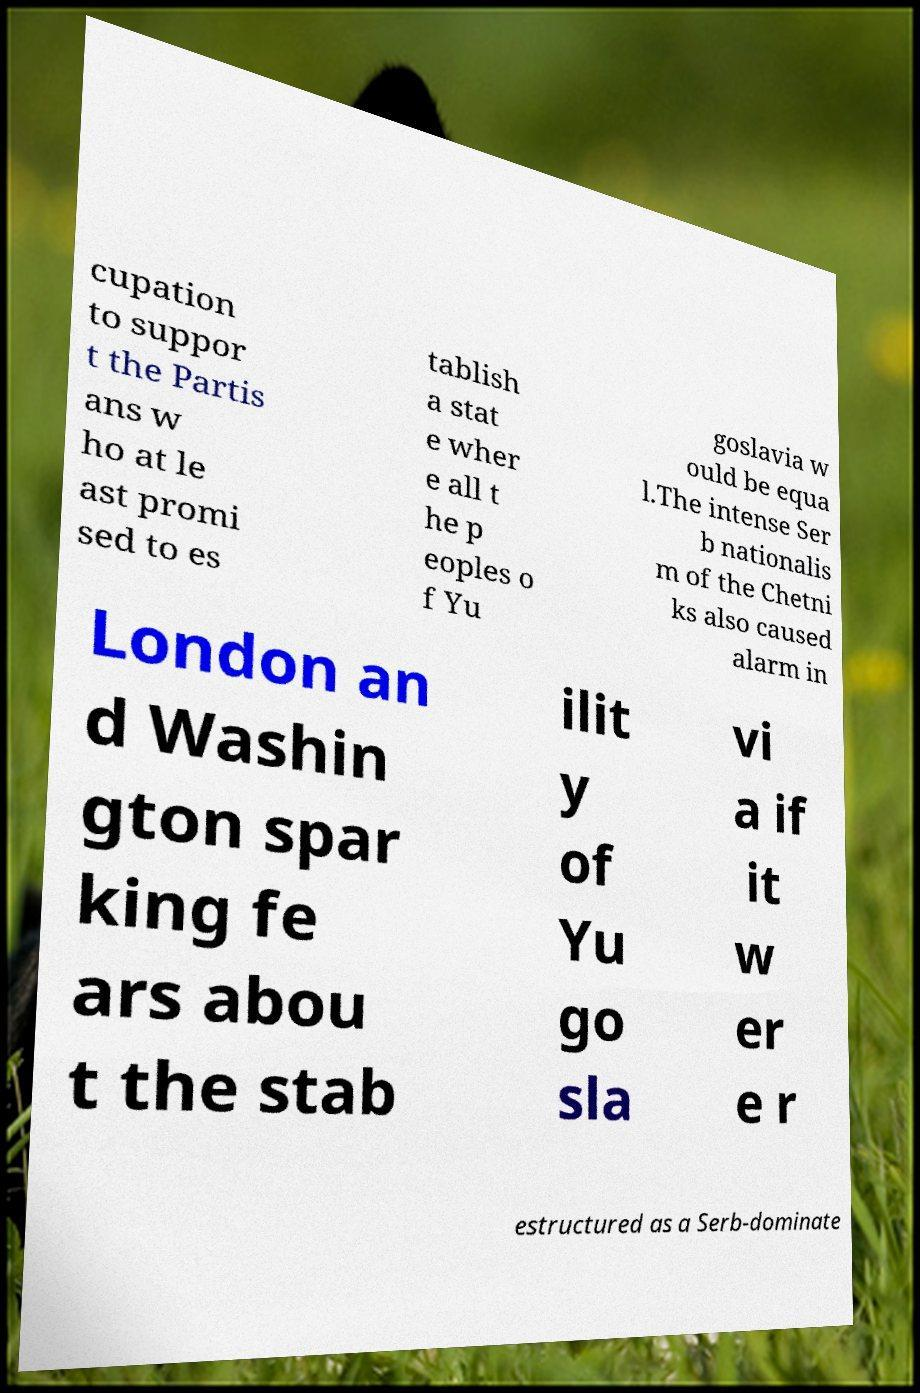Could you assist in decoding the text presented in this image and type it out clearly? cupation to suppor t the Partis ans w ho at le ast promi sed to es tablish a stat e wher e all t he p eoples o f Yu goslavia w ould be equa l.The intense Ser b nationalis m of the Chetni ks also caused alarm in London an d Washin gton spar king fe ars abou t the stab ilit y of Yu go sla vi a if it w er e r estructured as a Serb-dominate 